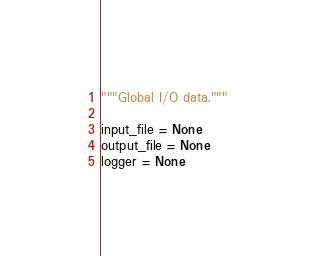Convert code to text. <code><loc_0><loc_0><loc_500><loc_500><_Python_>"""Global I/O data."""

input_file = None
output_file = None
logger = None
</code> 